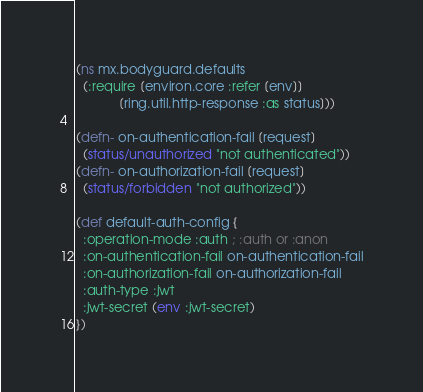<code> <loc_0><loc_0><loc_500><loc_500><_Clojure_>(ns mx.bodyguard.defaults
  (:require [environ.core :refer [env]]
            [ring.util.http-response :as status]))

(defn- on-authentication-fail [request]
  (status/unauthorized "not authenticated"))
(defn- on-authorization-fail [request]
  (status/forbidden "not authorized"))

(def default-auth-config {
  :operation-mode :auth ; :auth or :anon
  :on-authentication-fail on-authentication-fail
  :on-authorization-fail on-authorization-fail
  :auth-type :jwt
  :jwt-secret (env :jwt-secret)
})
</code> 